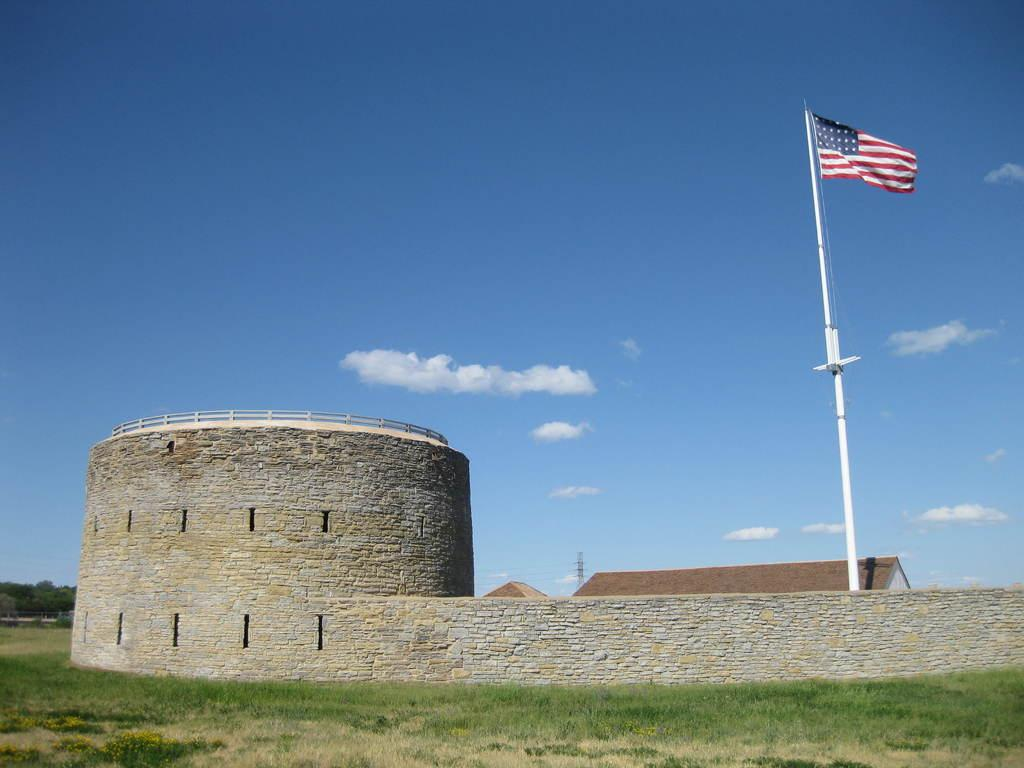What type of structure is the main subject of the image? There is a castle in the image. Can you describe any specific features of the castle? The castle has a flag on the right side. What is located behind the castle in the image? There is a home behind the castle. What type of terrain is the home situated on? The home is on a grassland. What is visible in the background of the image? The sky is visible in the image, and clouds are present in the sky. What type of cent can be seen interacting with the flag on the castle in the image? There is no cent present in the image, and therefore no such interaction can be observed. Who is the representative of the castle in the image? There is no specific representative of the castle depicted in the image. 